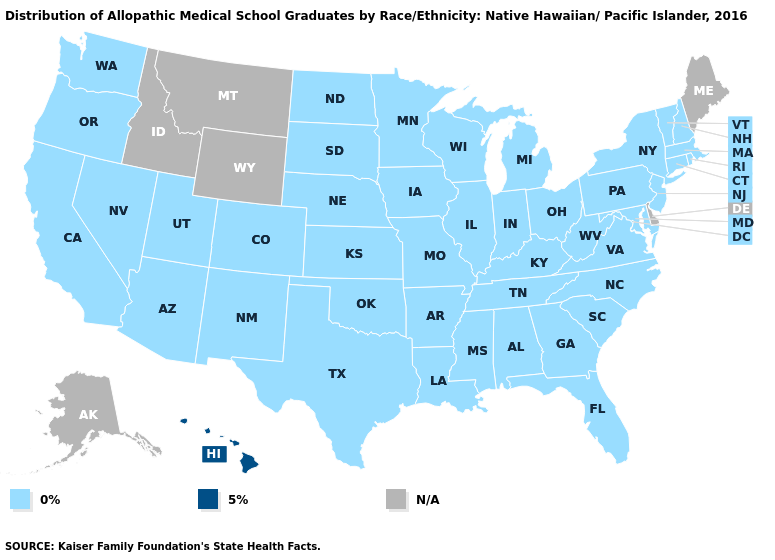Name the states that have a value in the range 0%?
Write a very short answer. Alabama, Arizona, Arkansas, California, Colorado, Connecticut, Florida, Georgia, Illinois, Indiana, Iowa, Kansas, Kentucky, Louisiana, Maryland, Massachusetts, Michigan, Minnesota, Mississippi, Missouri, Nebraska, Nevada, New Hampshire, New Jersey, New Mexico, New York, North Carolina, North Dakota, Ohio, Oklahoma, Oregon, Pennsylvania, Rhode Island, South Carolina, South Dakota, Tennessee, Texas, Utah, Vermont, Virginia, Washington, West Virginia, Wisconsin. Name the states that have a value in the range N/A?
Be succinct. Alaska, Delaware, Idaho, Maine, Montana, Wyoming. Name the states that have a value in the range N/A?
Write a very short answer. Alaska, Delaware, Idaho, Maine, Montana, Wyoming. Which states have the lowest value in the South?
Give a very brief answer. Alabama, Arkansas, Florida, Georgia, Kentucky, Louisiana, Maryland, Mississippi, North Carolina, Oklahoma, South Carolina, Tennessee, Texas, Virginia, West Virginia. Which states have the lowest value in the Northeast?
Give a very brief answer. Connecticut, Massachusetts, New Hampshire, New Jersey, New York, Pennsylvania, Rhode Island, Vermont. What is the highest value in the Northeast ?
Give a very brief answer. 0%. Does Hawaii have the lowest value in the USA?
Answer briefly. No. What is the value of Georgia?
Quick response, please. 0%. What is the highest value in the West ?
Write a very short answer. 5%. Which states have the lowest value in the USA?
Quick response, please. Alabama, Arizona, Arkansas, California, Colorado, Connecticut, Florida, Georgia, Illinois, Indiana, Iowa, Kansas, Kentucky, Louisiana, Maryland, Massachusetts, Michigan, Minnesota, Mississippi, Missouri, Nebraska, Nevada, New Hampshire, New Jersey, New Mexico, New York, North Carolina, North Dakota, Ohio, Oklahoma, Oregon, Pennsylvania, Rhode Island, South Carolina, South Dakota, Tennessee, Texas, Utah, Vermont, Virginia, Washington, West Virginia, Wisconsin. 